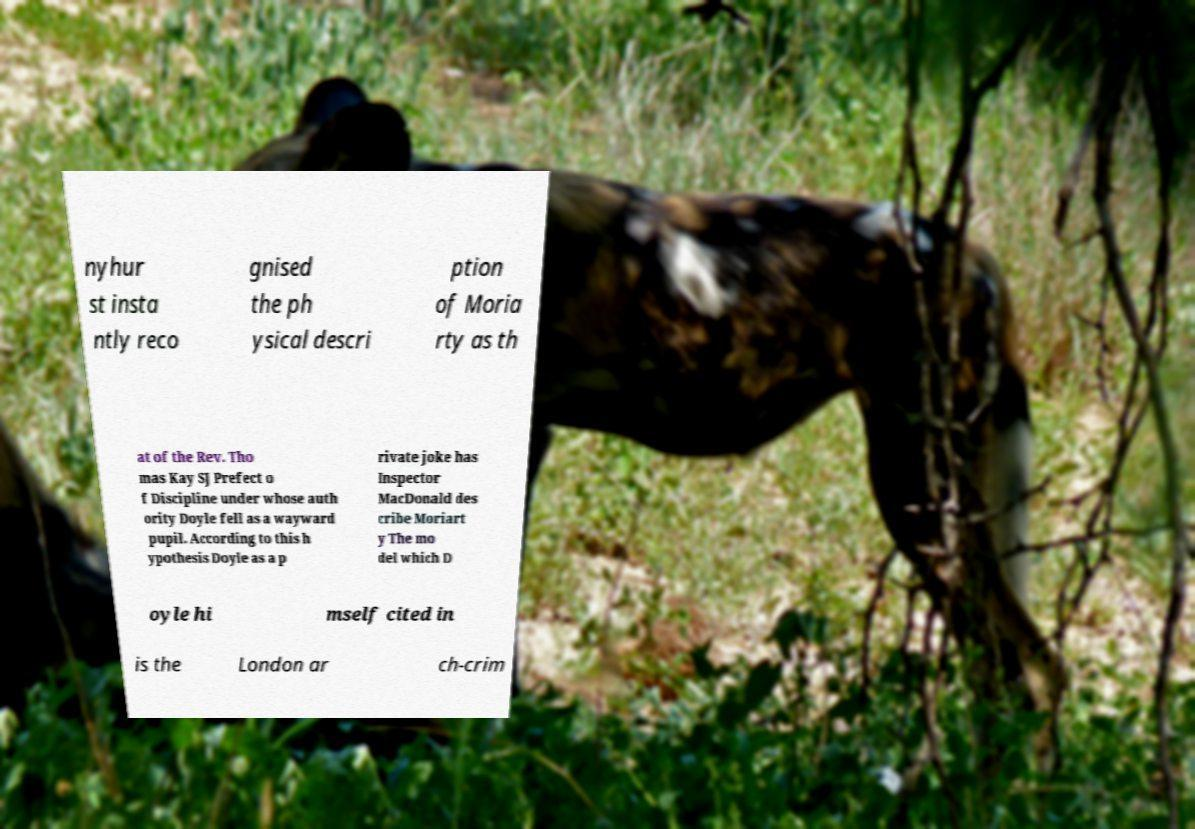I need the written content from this picture converted into text. Can you do that? nyhur st insta ntly reco gnised the ph ysical descri ption of Moria rty as th at of the Rev. Tho mas Kay SJ Prefect o f Discipline under whose auth ority Doyle fell as a wayward pupil. According to this h ypothesis Doyle as a p rivate joke has Inspector MacDonald des cribe Moriart y The mo del which D oyle hi mself cited in is the London ar ch-crim 